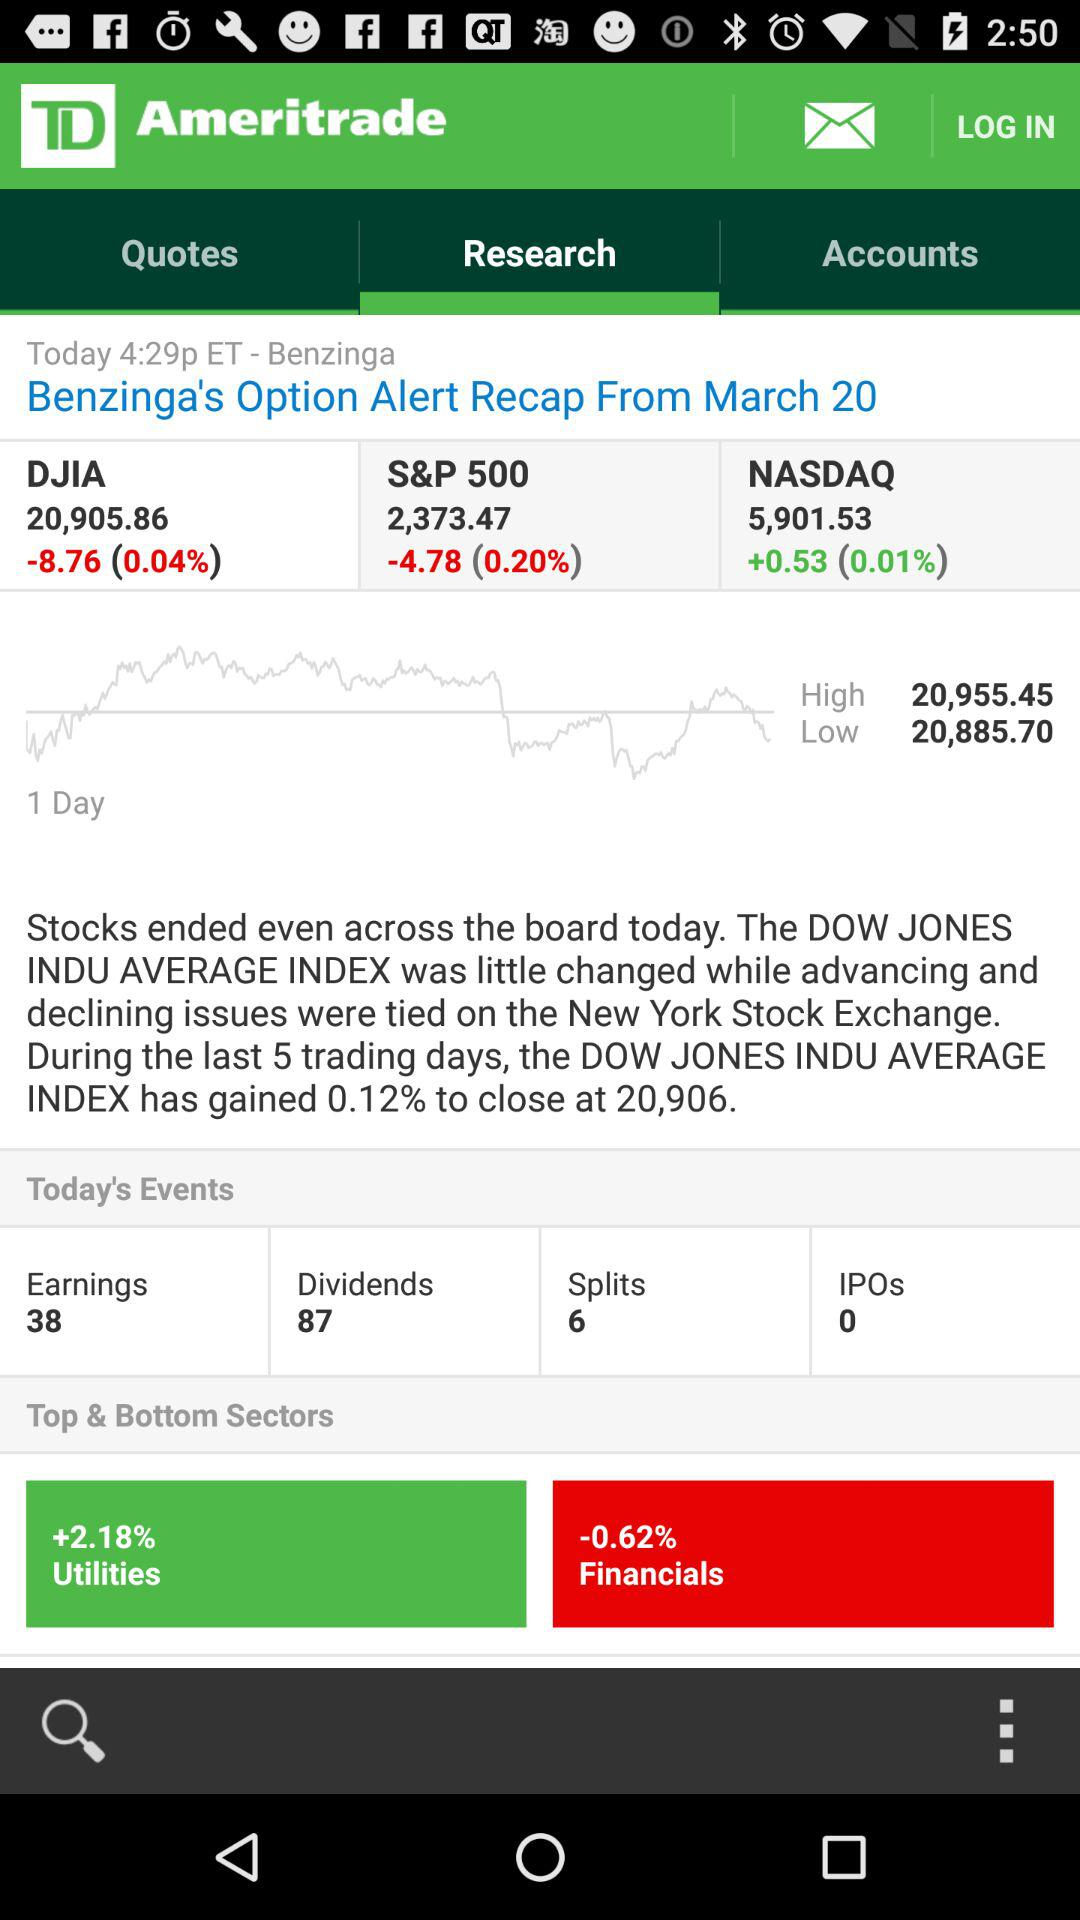Can you explain the numbers listed at the top of the image? Certainly! The numbers represent the closing values for three major stock indices on a given day. The DJIA, or Dow Jones Industrial Average, ended at 20,905.86, the S&P 500 closed at 2,373.47, and the NASDAQ finished at 5,901.53. What do the changes like '+0.53' next to NASDAQ mean? The '+0.53' indicates that the NASDAQ index had a gain, increasing by 0.53 points from its previous close, which is a slight upward movement reflecting a 0.01% increase in its value. 